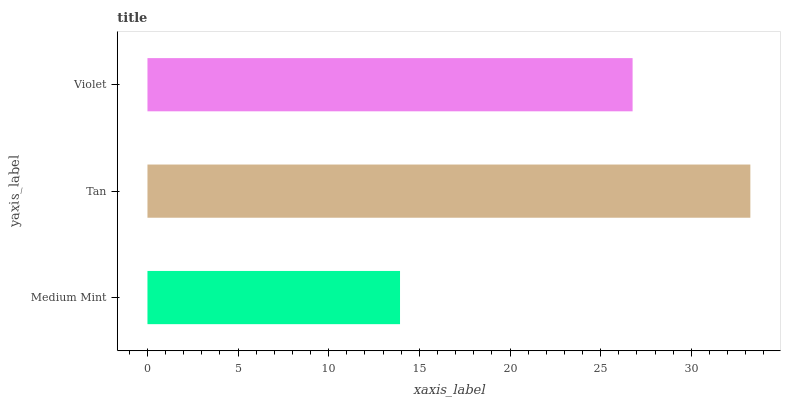Is Medium Mint the minimum?
Answer yes or no. Yes. Is Tan the maximum?
Answer yes or no. Yes. Is Violet the minimum?
Answer yes or no. No. Is Violet the maximum?
Answer yes or no. No. Is Tan greater than Violet?
Answer yes or no. Yes. Is Violet less than Tan?
Answer yes or no. Yes. Is Violet greater than Tan?
Answer yes or no. No. Is Tan less than Violet?
Answer yes or no. No. Is Violet the high median?
Answer yes or no. Yes. Is Violet the low median?
Answer yes or no. Yes. Is Tan the high median?
Answer yes or no. No. Is Medium Mint the low median?
Answer yes or no. No. 